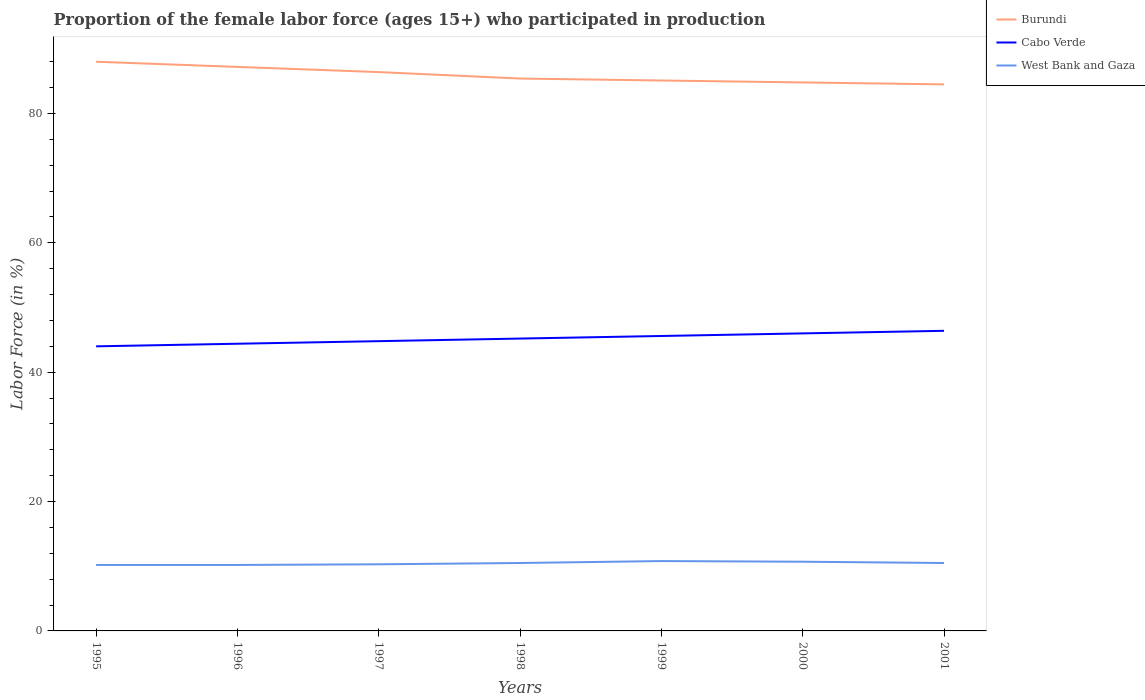How many different coloured lines are there?
Give a very brief answer. 3. Across all years, what is the maximum proportion of the female labor force who participated in production in Burundi?
Give a very brief answer. 84.5. In which year was the proportion of the female labor force who participated in production in Burundi maximum?
Your answer should be very brief. 2001. What is the total proportion of the female labor force who participated in production in West Bank and Gaza in the graph?
Your answer should be compact. -0.6. What is the difference between the highest and the second highest proportion of the female labor force who participated in production in Cabo Verde?
Make the answer very short. 2.4. What is the difference between the highest and the lowest proportion of the female labor force who participated in production in Burundi?
Make the answer very short. 3. How many years are there in the graph?
Your answer should be compact. 7. Where does the legend appear in the graph?
Make the answer very short. Top right. What is the title of the graph?
Offer a terse response. Proportion of the female labor force (ages 15+) who participated in production. Does "Turkmenistan" appear as one of the legend labels in the graph?
Your answer should be compact. No. What is the label or title of the X-axis?
Your response must be concise. Years. What is the label or title of the Y-axis?
Ensure brevity in your answer.  Labor Force (in %). What is the Labor Force (in %) of Burundi in 1995?
Provide a succinct answer. 88. What is the Labor Force (in %) in West Bank and Gaza in 1995?
Make the answer very short. 10.2. What is the Labor Force (in %) in Burundi in 1996?
Your answer should be compact. 87.2. What is the Labor Force (in %) of Cabo Verde in 1996?
Make the answer very short. 44.4. What is the Labor Force (in %) of West Bank and Gaza in 1996?
Your response must be concise. 10.2. What is the Labor Force (in %) in Burundi in 1997?
Your answer should be compact. 86.4. What is the Labor Force (in %) of Cabo Verde in 1997?
Give a very brief answer. 44.8. What is the Labor Force (in %) of West Bank and Gaza in 1997?
Make the answer very short. 10.3. What is the Labor Force (in %) in Burundi in 1998?
Your response must be concise. 85.4. What is the Labor Force (in %) of Cabo Verde in 1998?
Offer a very short reply. 45.2. What is the Labor Force (in %) of Burundi in 1999?
Provide a short and direct response. 85.1. What is the Labor Force (in %) of Cabo Verde in 1999?
Your answer should be very brief. 45.6. What is the Labor Force (in %) in West Bank and Gaza in 1999?
Your answer should be compact. 10.8. What is the Labor Force (in %) of Burundi in 2000?
Provide a succinct answer. 84.8. What is the Labor Force (in %) in Cabo Verde in 2000?
Provide a succinct answer. 46. What is the Labor Force (in %) of West Bank and Gaza in 2000?
Give a very brief answer. 10.7. What is the Labor Force (in %) of Burundi in 2001?
Your answer should be compact. 84.5. What is the Labor Force (in %) of Cabo Verde in 2001?
Ensure brevity in your answer.  46.4. What is the Labor Force (in %) of West Bank and Gaza in 2001?
Offer a very short reply. 10.5. Across all years, what is the maximum Labor Force (in %) of Burundi?
Give a very brief answer. 88. Across all years, what is the maximum Labor Force (in %) in Cabo Verde?
Your response must be concise. 46.4. Across all years, what is the maximum Labor Force (in %) of West Bank and Gaza?
Your response must be concise. 10.8. Across all years, what is the minimum Labor Force (in %) in Burundi?
Make the answer very short. 84.5. Across all years, what is the minimum Labor Force (in %) in Cabo Verde?
Give a very brief answer. 44. Across all years, what is the minimum Labor Force (in %) in West Bank and Gaza?
Make the answer very short. 10.2. What is the total Labor Force (in %) in Burundi in the graph?
Offer a very short reply. 601.4. What is the total Labor Force (in %) of Cabo Verde in the graph?
Your answer should be very brief. 316.4. What is the total Labor Force (in %) of West Bank and Gaza in the graph?
Give a very brief answer. 73.2. What is the difference between the Labor Force (in %) in Cabo Verde in 1995 and that in 1996?
Your answer should be compact. -0.4. What is the difference between the Labor Force (in %) of Cabo Verde in 1995 and that in 1997?
Your response must be concise. -0.8. What is the difference between the Labor Force (in %) of Burundi in 1995 and that in 1998?
Your answer should be compact. 2.6. What is the difference between the Labor Force (in %) of Cabo Verde in 1995 and that in 1999?
Your response must be concise. -1.6. What is the difference between the Labor Force (in %) in West Bank and Gaza in 1995 and that in 1999?
Make the answer very short. -0.6. What is the difference between the Labor Force (in %) of Burundi in 1995 and that in 2000?
Your answer should be very brief. 3.2. What is the difference between the Labor Force (in %) in West Bank and Gaza in 1995 and that in 2000?
Provide a short and direct response. -0.5. What is the difference between the Labor Force (in %) in Burundi in 1996 and that in 1997?
Ensure brevity in your answer.  0.8. What is the difference between the Labor Force (in %) in Cabo Verde in 1996 and that in 1997?
Your answer should be very brief. -0.4. What is the difference between the Labor Force (in %) in Cabo Verde in 1996 and that in 1998?
Ensure brevity in your answer.  -0.8. What is the difference between the Labor Force (in %) of West Bank and Gaza in 1996 and that in 1998?
Keep it short and to the point. -0.3. What is the difference between the Labor Force (in %) in Burundi in 1996 and that in 1999?
Give a very brief answer. 2.1. What is the difference between the Labor Force (in %) in Cabo Verde in 1996 and that in 1999?
Offer a very short reply. -1.2. What is the difference between the Labor Force (in %) of West Bank and Gaza in 1996 and that in 1999?
Ensure brevity in your answer.  -0.6. What is the difference between the Labor Force (in %) of Burundi in 1996 and that in 2000?
Provide a short and direct response. 2.4. What is the difference between the Labor Force (in %) in Cabo Verde in 1996 and that in 2000?
Provide a succinct answer. -1.6. What is the difference between the Labor Force (in %) of West Bank and Gaza in 1996 and that in 2000?
Your answer should be compact. -0.5. What is the difference between the Labor Force (in %) of Cabo Verde in 1996 and that in 2001?
Your answer should be compact. -2. What is the difference between the Labor Force (in %) of West Bank and Gaza in 1996 and that in 2001?
Provide a succinct answer. -0.3. What is the difference between the Labor Force (in %) in Burundi in 1997 and that in 1999?
Provide a succinct answer. 1.3. What is the difference between the Labor Force (in %) of West Bank and Gaza in 1997 and that in 1999?
Your response must be concise. -0.5. What is the difference between the Labor Force (in %) of Burundi in 1997 and that in 2000?
Ensure brevity in your answer.  1.6. What is the difference between the Labor Force (in %) of Cabo Verde in 1997 and that in 2000?
Offer a very short reply. -1.2. What is the difference between the Labor Force (in %) of Burundi in 1997 and that in 2001?
Your response must be concise. 1.9. What is the difference between the Labor Force (in %) of Cabo Verde in 1997 and that in 2001?
Keep it short and to the point. -1.6. What is the difference between the Labor Force (in %) in West Bank and Gaza in 1997 and that in 2001?
Keep it short and to the point. -0.2. What is the difference between the Labor Force (in %) in Burundi in 1998 and that in 1999?
Offer a very short reply. 0.3. What is the difference between the Labor Force (in %) of Cabo Verde in 1998 and that in 1999?
Your answer should be compact. -0.4. What is the difference between the Labor Force (in %) in West Bank and Gaza in 1998 and that in 1999?
Offer a very short reply. -0.3. What is the difference between the Labor Force (in %) in Burundi in 1998 and that in 2000?
Provide a succinct answer. 0.6. What is the difference between the Labor Force (in %) of Cabo Verde in 1998 and that in 2001?
Your answer should be compact. -1.2. What is the difference between the Labor Force (in %) of Cabo Verde in 1999 and that in 2000?
Offer a terse response. -0.4. What is the difference between the Labor Force (in %) of Cabo Verde in 1999 and that in 2001?
Make the answer very short. -0.8. What is the difference between the Labor Force (in %) in Burundi in 1995 and the Labor Force (in %) in Cabo Verde in 1996?
Offer a terse response. 43.6. What is the difference between the Labor Force (in %) in Burundi in 1995 and the Labor Force (in %) in West Bank and Gaza in 1996?
Your answer should be very brief. 77.8. What is the difference between the Labor Force (in %) in Cabo Verde in 1995 and the Labor Force (in %) in West Bank and Gaza in 1996?
Your answer should be very brief. 33.8. What is the difference between the Labor Force (in %) in Burundi in 1995 and the Labor Force (in %) in Cabo Verde in 1997?
Keep it short and to the point. 43.2. What is the difference between the Labor Force (in %) of Burundi in 1995 and the Labor Force (in %) of West Bank and Gaza in 1997?
Provide a short and direct response. 77.7. What is the difference between the Labor Force (in %) of Cabo Verde in 1995 and the Labor Force (in %) of West Bank and Gaza in 1997?
Give a very brief answer. 33.7. What is the difference between the Labor Force (in %) in Burundi in 1995 and the Labor Force (in %) in Cabo Verde in 1998?
Provide a succinct answer. 42.8. What is the difference between the Labor Force (in %) of Burundi in 1995 and the Labor Force (in %) of West Bank and Gaza in 1998?
Your answer should be very brief. 77.5. What is the difference between the Labor Force (in %) in Cabo Verde in 1995 and the Labor Force (in %) in West Bank and Gaza in 1998?
Offer a terse response. 33.5. What is the difference between the Labor Force (in %) in Burundi in 1995 and the Labor Force (in %) in Cabo Verde in 1999?
Your response must be concise. 42.4. What is the difference between the Labor Force (in %) in Burundi in 1995 and the Labor Force (in %) in West Bank and Gaza in 1999?
Your response must be concise. 77.2. What is the difference between the Labor Force (in %) of Cabo Verde in 1995 and the Labor Force (in %) of West Bank and Gaza in 1999?
Keep it short and to the point. 33.2. What is the difference between the Labor Force (in %) of Burundi in 1995 and the Labor Force (in %) of West Bank and Gaza in 2000?
Offer a terse response. 77.3. What is the difference between the Labor Force (in %) in Cabo Verde in 1995 and the Labor Force (in %) in West Bank and Gaza in 2000?
Your answer should be very brief. 33.3. What is the difference between the Labor Force (in %) in Burundi in 1995 and the Labor Force (in %) in Cabo Verde in 2001?
Give a very brief answer. 41.6. What is the difference between the Labor Force (in %) in Burundi in 1995 and the Labor Force (in %) in West Bank and Gaza in 2001?
Your answer should be compact. 77.5. What is the difference between the Labor Force (in %) of Cabo Verde in 1995 and the Labor Force (in %) of West Bank and Gaza in 2001?
Your answer should be compact. 33.5. What is the difference between the Labor Force (in %) in Burundi in 1996 and the Labor Force (in %) in Cabo Verde in 1997?
Your response must be concise. 42.4. What is the difference between the Labor Force (in %) of Burundi in 1996 and the Labor Force (in %) of West Bank and Gaza in 1997?
Your answer should be compact. 76.9. What is the difference between the Labor Force (in %) of Cabo Verde in 1996 and the Labor Force (in %) of West Bank and Gaza in 1997?
Give a very brief answer. 34.1. What is the difference between the Labor Force (in %) in Burundi in 1996 and the Labor Force (in %) in West Bank and Gaza in 1998?
Give a very brief answer. 76.7. What is the difference between the Labor Force (in %) of Cabo Verde in 1996 and the Labor Force (in %) of West Bank and Gaza in 1998?
Your response must be concise. 33.9. What is the difference between the Labor Force (in %) in Burundi in 1996 and the Labor Force (in %) in Cabo Verde in 1999?
Your answer should be compact. 41.6. What is the difference between the Labor Force (in %) of Burundi in 1996 and the Labor Force (in %) of West Bank and Gaza in 1999?
Keep it short and to the point. 76.4. What is the difference between the Labor Force (in %) in Cabo Verde in 1996 and the Labor Force (in %) in West Bank and Gaza in 1999?
Make the answer very short. 33.6. What is the difference between the Labor Force (in %) in Burundi in 1996 and the Labor Force (in %) in Cabo Verde in 2000?
Ensure brevity in your answer.  41.2. What is the difference between the Labor Force (in %) of Burundi in 1996 and the Labor Force (in %) of West Bank and Gaza in 2000?
Keep it short and to the point. 76.5. What is the difference between the Labor Force (in %) of Cabo Verde in 1996 and the Labor Force (in %) of West Bank and Gaza in 2000?
Provide a succinct answer. 33.7. What is the difference between the Labor Force (in %) of Burundi in 1996 and the Labor Force (in %) of Cabo Verde in 2001?
Ensure brevity in your answer.  40.8. What is the difference between the Labor Force (in %) of Burundi in 1996 and the Labor Force (in %) of West Bank and Gaza in 2001?
Offer a terse response. 76.7. What is the difference between the Labor Force (in %) of Cabo Verde in 1996 and the Labor Force (in %) of West Bank and Gaza in 2001?
Your answer should be compact. 33.9. What is the difference between the Labor Force (in %) in Burundi in 1997 and the Labor Force (in %) in Cabo Verde in 1998?
Provide a short and direct response. 41.2. What is the difference between the Labor Force (in %) of Burundi in 1997 and the Labor Force (in %) of West Bank and Gaza in 1998?
Provide a short and direct response. 75.9. What is the difference between the Labor Force (in %) of Cabo Verde in 1997 and the Labor Force (in %) of West Bank and Gaza in 1998?
Offer a very short reply. 34.3. What is the difference between the Labor Force (in %) in Burundi in 1997 and the Labor Force (in %) in Cabo Verde in 1999?
Offer a very short reply. 40.8. What is the difference between the Labor Force (in %) in Burundi in 1997 and the Labor Force (in %) in West Bank and Gaza in 1999?
Give a very brief answer. 75.6. What is the difference between the Labor Force (in %) in Cabo Verde in 1997 and the Labor Force (in %) in West Bank and Gaza in 1999?
Offer a very short reply. 34. What is the difference between the Labor Force (in %) in Burundi in 1997 and the Labor Force (in %) in Cabo Verde in 2000?
Make the answer very short. 40.4. What is the difference between the Labor Force (in %) of Burundi in 1997 and the Labor Force (in %) of West Bank and Gaza in 2000?
Provide a succinct answer. 75.7. What is the difference between the Labor Force (in %) in Cabo Verde in 1997 and the Labor Force (in %) in West Bank and Gaza in 2000?
Give a very brief answer. 34.1. What is the difference between the Labor Force (in %) of Burundi in 1997 and the Labor Force (in %) of West Bank and Gaza in 2001?
Keep it short and to the point. 75.9. What is the difference between the Labor Force (in %) in Cabo Verde in 1997 and the Labor Force (in %) in West Bank and Gaza in 2001?
Your response must be concise. 34.3. What is the difference between the Labor Force (in %) in Burundi in 1998 and the Labor Force (in %) in Cabo Verde in 1999?
Your response must be concise. 39.8. What is the difference between the Labor Force (in %) in Burundi in 1998 and the Labor Force (in %) in West Bank and Gaza in 1999?
Ensure brevity in your answer.  74.6. What is the difference between the Labor Force (in %) of Cabo Verde in 1998 and the Labor Force (in %) of West Bank and Gaza in 1999?
Your answer should be compact. 34.4. What is the difference between the Labor Force (in %) in Burundi in 1998 and the Labor Force (in %) in Cabo Verde in 2000?
Give a very brief answer. 39.4. What is the difference between the Labor Force (in %) of Burundi in 1998 and the Labor Force (in %) of West Bank and Gaza in 2000?
Provide a succinct answer. 74.7. What is the difference between the Labor Force (in %) in Cabo Verde in 1998 and the Labor Force (in %) in West Bank and Gaza in 2000?
Provide a succinct answer. 34.5. What is the difference between the Labor Force (in %) of Burundi in 1998 and the Labor Force (in %) of Cabo Verde in 2001?
Your answer should be compact. 39. What is the difference between the Labor Force (in %) in Burundi in 1998 and the Labor Force (in %) in West Bank and Gaza in 2001?
Provide a short and direct response. 74.9. What is the difference between the Labor Force (in %) of Cabo Verde in 1998 and the Labor Force (in %) of West Bank and Gaza in 2001?
Make the answer very short. 34.7. What is the difference between the Labor Force (in %) in Burundi in 1999 and the Labor Force (in %) in Cabo Verde in 2000?
Provide a short and direct response. 39.1. What is the difference between the Labor Force (in %) of Burundi in 1999 and the Labor Force (in %) of West Bank and Gaza in 2000?
Ensure brevity in your answer.  74.4. What is the difference between the Labor Force (in %) in Cabo Verde in 1999 and the Labor Force (in %) in West Bank and Gaza in 2000?
Give a very brief answer. 34.9. What is the difference between the Labor Force (in %) of Burundi in 1999 and the Labor Force (in %) of Cabo Verde in 2001?
Provide a succinct answer. 38.7. What is the difference between the Labor Force (in %) in Burundi in 1999 and the Labor Force (in %) in West Bank and Gaza in 2001?
Make the answer very short. 74.6. What is the difference between the Labor Force (in %) of Cabo Verde in 1999 and the Labor Force (in %) of West Bank and Gaza in 2001?
Make the answer very short. 35.1. What is the difference between the Labor Force (in %) of Burundi in 2000 and the Labor Force (in %) of Cabo Verde in 2001?
Provide a succinct answer. 38.4. What is the difference between the Labor Force (in %) in Burundi in 2000 and the Labor Force (in %) in West Bank and Gaza in 2001?
Provide a short and direct response. 74.3. What is the difference between the Labor Force (in %) of Cabo Verde in 2000 and the Labor Force (in %) of West Bank and Gaza in 2001?
Offer a very short reply. 35.5. What is the average Labor Force (in %) in Burundi per year?
Your answer should be compact. 85.91. What is the average Labor Force (in %) of Cabo Verde per year?
Make the answer very short. 45.2. What is the average Labor Force (in %) of West Bank and Gaza per year?
Make the answer very short. 10.46. In the year 1995, what is the difference between the Labor Force (in %) of Burundi and Labor Force (in %) of West Bank and Gaza?
Your response must be concise. 77.8. In the year 1995, what is the difference between the Labor Force (in %) in Cabo Verde and Labor Force (in %) in West Bank and Gaza?
Offer a very short reply. 33.8. In the year 1996, what is the difference between the Labor Force (in %) of Burundi and Labor Force (in %) of Cabo Verde?
Provide a succinct answer. 42.8. In the year 1996, what is the difference between the Labor Force (in %) in Burundi and Labor Force (in %) in West Bank and Gaza?
Provide a succinct answer. 77. In the year 1996, what is the difference between the Labor Force (in %) in Cabo Verde and Labor Force (in %) in West Bank and Gaza?
Your response must be concise. 34.2. In the year 1997, what is the difference between the Labor Force (in %) in Burundi and Labor Force (in %) in Cabo Verde?
Provide a succinct answer. 41.6. In the year 1997, what is the difference between the Labor Force (in %) of Burundi and Labor Force (in %) of West Bank and Gaza?
Offer a terse response. 76.1. In the year 1997, what is the difference between the Labor Force (in %) in Cabo Verde and Labor Force (in %) in West Bank and Gaza?
Provide a succinct answer. 34.5. In the year 1998, what is the difference between the Labor Force (in %) of Burundi and Labor Force (in %) of Cabo Verde?
Offer a terse response. 40.2. In the year 1998, what is the difference between the Labor Force (in %) of Burundi and Labor Force (in %) of West Bank and Gaza?
Make the answer very short. 74.9. In the year 1998, what is the difference between the Labor Force (in %) in Cabo Verde and Labor Force (in %) in West Bank and Gaza?
Make the answer very short. 34.7. In the year 1999, what is the difference between the Labor Force (in %) in Burundi and Labor Force (in %) in Cabo Verde?
Your response must be concise. 39.5. In the year 1999, what is the difference between the Labor Force (in %) of Burundi and Labor Force (in %) of West Bank and Gaza?
Keep it short and to the point. 74.3. In the year 1999, what is the difference between the Labor Force (in %) of Cabo Verde and Labor Force (in %) of West Bank and Gaza?
Make the answer very short. 34.8. In the year 2000, what is the difference between the Labor Force (in %) in Burundi and Labor Force (in %) in Cabo Verde?
Offer a terse response. 38.8. In the year 2000, what is the difference between the Labor Force (in %) of Burundi and Labor Force (in %) of West Bank and Gaza?
Offer a terse response. 74.1. In the year 2000, what is the difference between the Labor Force (in %) in Cabo Verde and Labor Force (in %) in West Bank and Gaza?
Give a very brief answer. 35.3. In the year 2001, what is the difference between the Labor Force (in %) in Burundi and Labor Force (in %) in Cabo Verde?
Your answer should be compact. 38.1. In the year 2001, what is the difference between the Labor Force (in %) in Burundi and Labor Force (in %) in West Bank and Gaza?
Offer a very short reply. 74. In the year 2001, what is the difference between the Labor Force (in %) in Cabo Verde and Labor Force (in %) in West Bank and Gaza?
Your response must be concise. 35.9. What is the ratio of the Labor Force (in %) of Burundi in 1995 to that in 1996?
Give a very brief answer. 1.01. What is the ratio of the Labor Force (in %) in Cabo Verde in 1995 to that in 1996?
Offer a very short reply. 0.99. What is the ratio of the Labor Force (in %) in West Bank and Gaza in 1995 to that in 1996?
Provide a short and direct response. 1. What is the ratio of the Labor Force (in %) in Burundi in 1995 to that in 1997?
Keep it short and to the point. 1.02. What is the ratio of the Labor Force (in %) in Cabo Verde in 1995 to that in 1997?
Your answer should be very brief. 0.98. What is the ratio of the Labor Force (in %) of West Bank and Gaza in 1995 to that in 1997?
Offer a very short reply. 0.99. What is the ratio of the Labor Force (in %) in Burundi in 1995 to that in 1998?
Provide a short and direct response. 1.03. What is the ratio of the Labor Force (in %) in Cabo Verde in 1995 to that in 1998?
Make the answer very short. 0.97. What is the ratio of the Labor Force (in %) of West Bank and Gaza in 1995 to that in 1998?
Provide a short and direct response. 0.97. What is the ratio of the Labor Force (in %) of Burundi in 1995 to that in 1999?
Offer a very short reply. 1.03. What is the ratio of the Labor Force (in %) in Cabo Verde in 1995 to that in 1999?
Provide a succinct answer. 0.96. What is the ratio of the Labor Force (in %) of West Bank and Gaza in 1995 to that in 1999?
Offer a terse response. 0.94. What is the ratio of the Labor Force (in %) in Burundi in 1995 to that in 2000?
Keep it short and to the point. 1.04. What is the ratio of the Labor Force (in %) of Cabo Verde in 1995 to that in 2000?
Ensure brevity in your answer.  0.96. What is the ratio of the Labor Force (in %) of West Bank and Gaza in 1995 to that in 2000?
Give a very brief answer. 0.95. What is the ratio of the Labor Force (in %) in Burundi in 1995 to that in 2001?
Offer a terse response. 1.04. What is the ratio of the Labor Force (in %) of Cabo Verde in 1995 to that in 2001?
Your answer should be very brief. 0.95. What is the ratio of the Labor Force (in %) in West Bank and Gaza in 1995 to that in 2001?
Ensure brevity in your answer.  0.97. What is the ratio of the Labor Force (in %) of Burundi in 1996 to that in 1997?
Offer a terse response. 1.01. What is the ratio of the Labor Force (in %) in West Bank and Gaza in 1996 to that in 1997?
Make the answer very short. 0.99. What is the ratio of the Labor Force (in %) in Burundi in 1996 to that in 1998?
Keep it short and to the point. 1.02. What is the ratio of the Labor Force (in %) in Cabo Verde in 1996 to that in 1998?
Make the answer very short. 0.98. What is the ratio of the Labor Force (in %) of West Bank and Gaza in 1996 to that in 1998?
Offer a very short reply. 0.97. What is the ratio of the Labor Force (in %) of Burundi in 1996 to that in 1999?
Ensure brevity in your answer.  1.02. What is the ratio of the Labor Force (in %) of Cabo Verde in 1996 to that in 1999?
Keep it short and to the point. 0.97. What is the ratio of the Labor Force (in %) in West Bank and Gaza in 1996 to that in 1999?
Provide a succinct answer. 0.94. What is the ratio of the Labor Force (in %) of Burundi in 1996 to that in 2000?
Your answer should be compact. 1.03. What is the ratio of the Labor Force (in %) of Cabo Verde in 1996 to that in 2000?
Offer a very short reply. 0.97. What is the ratio of the Labor Force (in %) of West Bank and Gaza in 1996 to that in 2000?
Your answer should be compact. 0.95. What is the ratio of the Labor Force (in %) of Burundi in 1996 to that in 2001?
Ensure brevity in your answer.  1.03. What is the ratio of the Labor Force (in %) of Cabo Verde in 1996 to that in 2001?
Provide a short and direct response. 0.96. What is the ratio of the Labor Force (in %) of West Bank and Gaza in 1996 to that in 2001?
Offer a terse response. 0.97. What is the ratio of the Labor Force (in %) in Burundi in 1997 to that in 1998?
Provide a short and direct response. 1.01. What is the ratio of the Labor Force (in %) in Burundi in 1997 to that in 1999?
Provide a succinct answer. 1.02. What is the ratio of the Labor Force (in %) of Cabo Verde in 1997 to that in 1999?
Give a very brief answer. 0.98. What is the ratio of the Labor Force (in %) of West Bank and Gaza in 1997 to that in 1999?
Your answer should be compact. 0.95. What is the ratio of the Labor Force (in %) of Burundi in 1997 to that in 2000?
Your answer should be very brief. 1.02. What is the ratio of the Labor Force (in %) in Cabo Verde in 1997 to that in 2000?
Offer a very short reply. 0.97. What is the ratio of the Labor Force (in %) in West Bank and Gaza in 1997 to that in 2000?
Your response must be concise. 0.96. What is the ratio of the Labor Force (in %) in Burundi in 1997 to that in 2001?
Provide a succinct answer. 1.02. What is the ratio of the Labor Force (in %) in Cabo Verde in 1997 to that in 2001?
Provide a succinct answer. 0.97. What is the ratio of the Labor Force (in %) of West Bank and Gaza in 1998 to that in 1999?
Your answer should be compact. 0.97. What is the ratio of the Labor Force (in %) of Burundi in 1998 to that in 2000?
Offer a terse response. 1.01. What is the ratio of the Labor Force (in %) in Cabo Verde in 1998 to that in 2000?
Ensure brevity in your answer.  0.98. What is the ratio of the Labor Force (in %) in West Bank and Gaza in 1998 to that in 2000?
Your answer should be compact. 0.98. What is the ratio of the Labor Force (in %) of Burundi in 1998 to that in 2001?
Your answer should be very brief. 1.01. What is the ratio of the Labor Force (in %) in Cabo Verde in 1998 to that in 2001?
Ensure brevity in your answer.  0.97. What is the ratio of the Labor Force (in %) in West Bank and Gaza in 1998 to that in 2001?
Provide a succinct answer. 1. What is the ratio of the Labor Force (in %) of Burundi in 1999 to that in 2000?
Make the answer very short. 1. What is the ratio of the Labor Force (in %) in Cabo Verde in 1999 to that in 2000?
Your response must be concise. 0.99. What is the ratio of the Labor Force (in %) of West Bank and Gaza in 1999 to that in 2000?
Your response must be concise. 1.01. What is the ratio of the Labor Force (in %) of Burundi in 1999 to that in 2001?
Make the answer very short. 1.01. What is the ratio of the Labor Force (in %) of Cabo Verde in 1999 to that in 2001?
Your answer should be compact. 0.98. What is the ratio of the Labor Force (in %) in West Bank and Gaza in 1999 to that in 2001?
Give a very brief answer. 1.03. What is the ratio of the Labor Force (in %) in West Bank and Gaza in 2000 to that in 2001?
Provide a short and direct response. 1.02. What is the difference between the highest and the second highest Labor Force (in %) in Burundi?
Give a very brief answer. 0.8. What is the difference between the highest and the second highest Labor Force (in %) of Cabo Verde?
Your response must be concise. 0.4. What is the difference between the highest and the second highest Labor Force (in %) in West Bank and Gaza?
Give a very brief answer. 0.1. What is the difference between the highest and the lowest Labor Force (in %) in Burundi?
Ensure brevity in your answer.  3.5. 